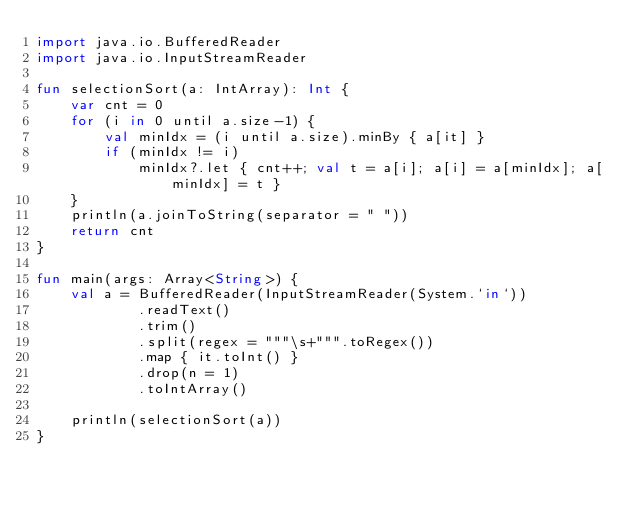Convert code to text. <code><loc_0><loc_0><loc_500><loc_500><_Kotlin_>import java.io.BufferedReader
import java.io.InputStreamReader

fun selectionSort(a: IntArray): Int {
    var cnt = 0
    for (i in 0 until a.size-1) {
        val minIdx = (i until a.size).minBy { a[it] }
        if (minIdx != i)
            minIdx?.let { cnt++; val t = a[i]; a[i] = a[minIdx]; a[minIdx] = t }
    }
    println(a.joinToString(separator = " "))
    return cnt
}

fun main(args: Array<String>) {
    val a = BufferedReader(InputStreamReader(System.`in`))
            .readText()
            .trim()
            .split(regex = """\s+""".toRegex())
            .map { it.toInt() }
            .drop(n = 1)
            .toIntArray()

    println(selectionSort(a))
}
</code> 